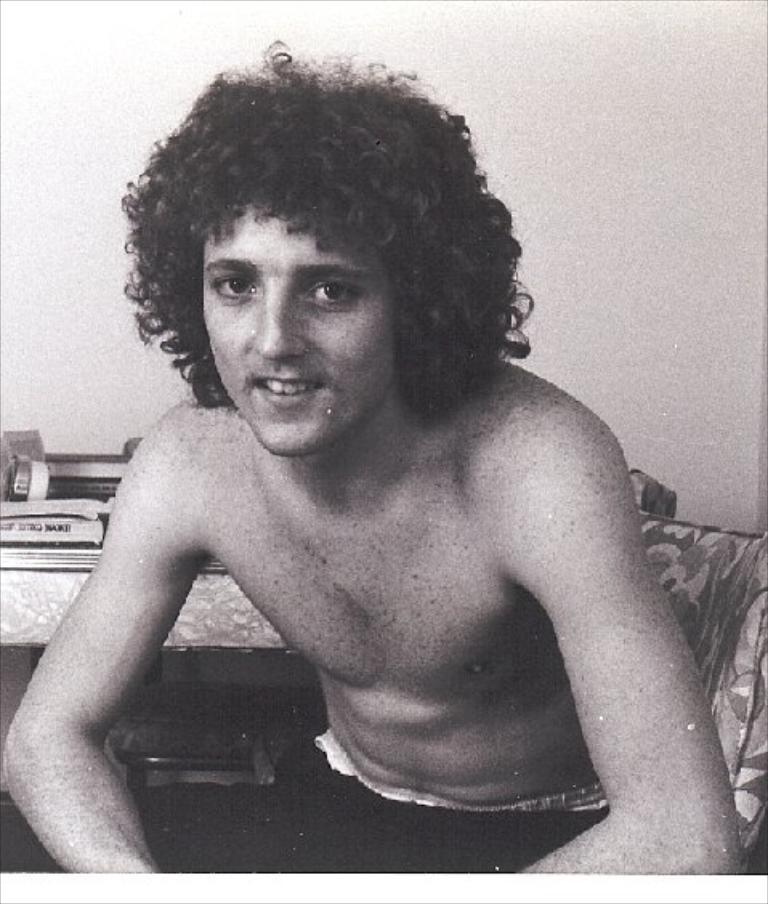What is the person in the image doing? The person is sitting on a chair in the image. Can you describe the setting of the image? There is a table in the background of the image. What type of can is visible on the person's desk in the image? There is no can visible on the person's desk in the image. 